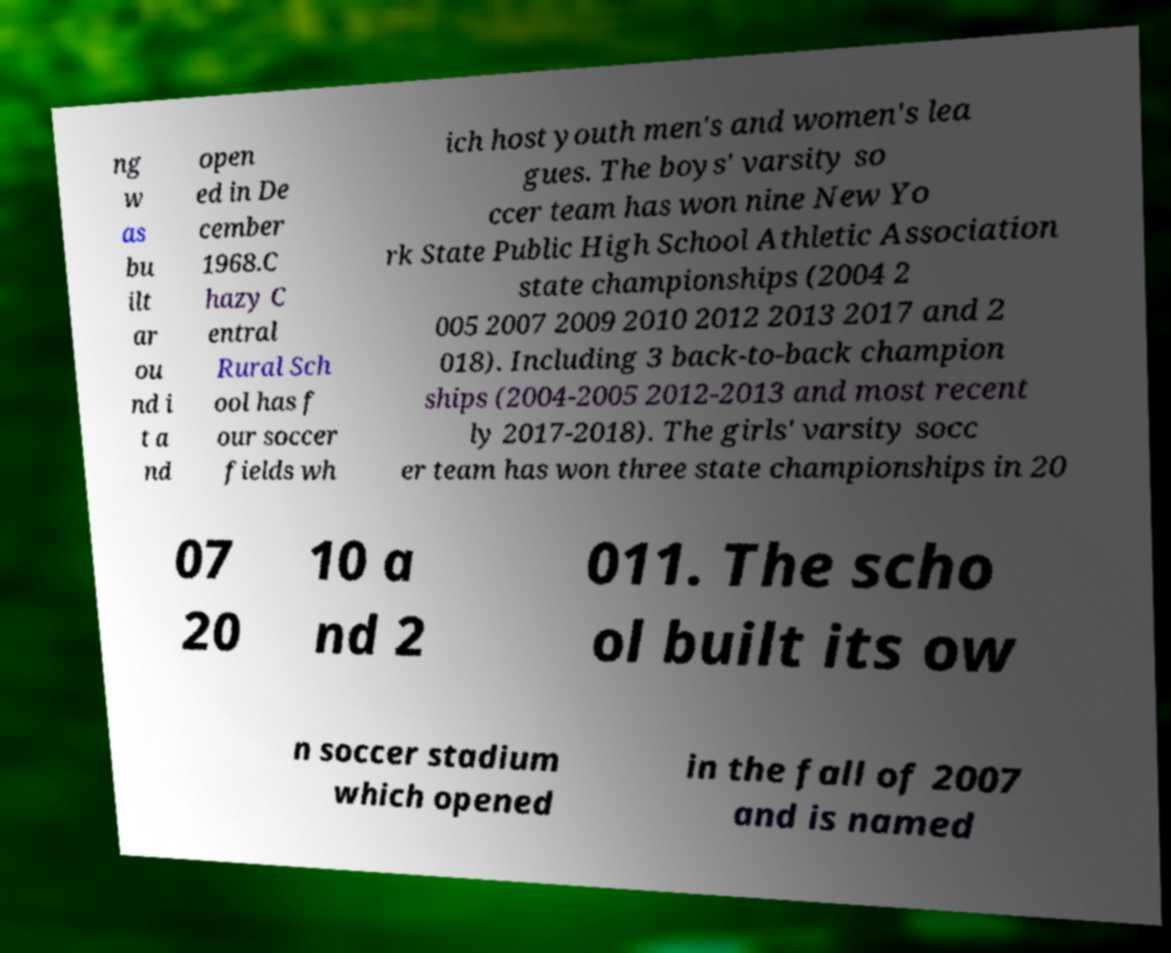I need the written content from this picture converted into text. Can you do that? ng w as bu ilt ar ou nd i t a nd open ed in De cember 1968.C hazy C entral Rural Sch ool has f our soccer fields wh ich host youth men's and women's lea gues. The boys' varsity so ccer team has won nine New Yo rk State Public High School Athletic Association state championships (2004 2 005 2007 2009 2010 2012 2013 2017 and 2 018). Including 3 back-to-back champion ships (2004-2005 2012-2013 and most recent ly 2017-2018). The girls' varsity socc er team has won three state championships in 20 07 20 10 a nd 2 011. The scho ol built its ow n soccer stadium which opened in the fall of 2007 and is named 